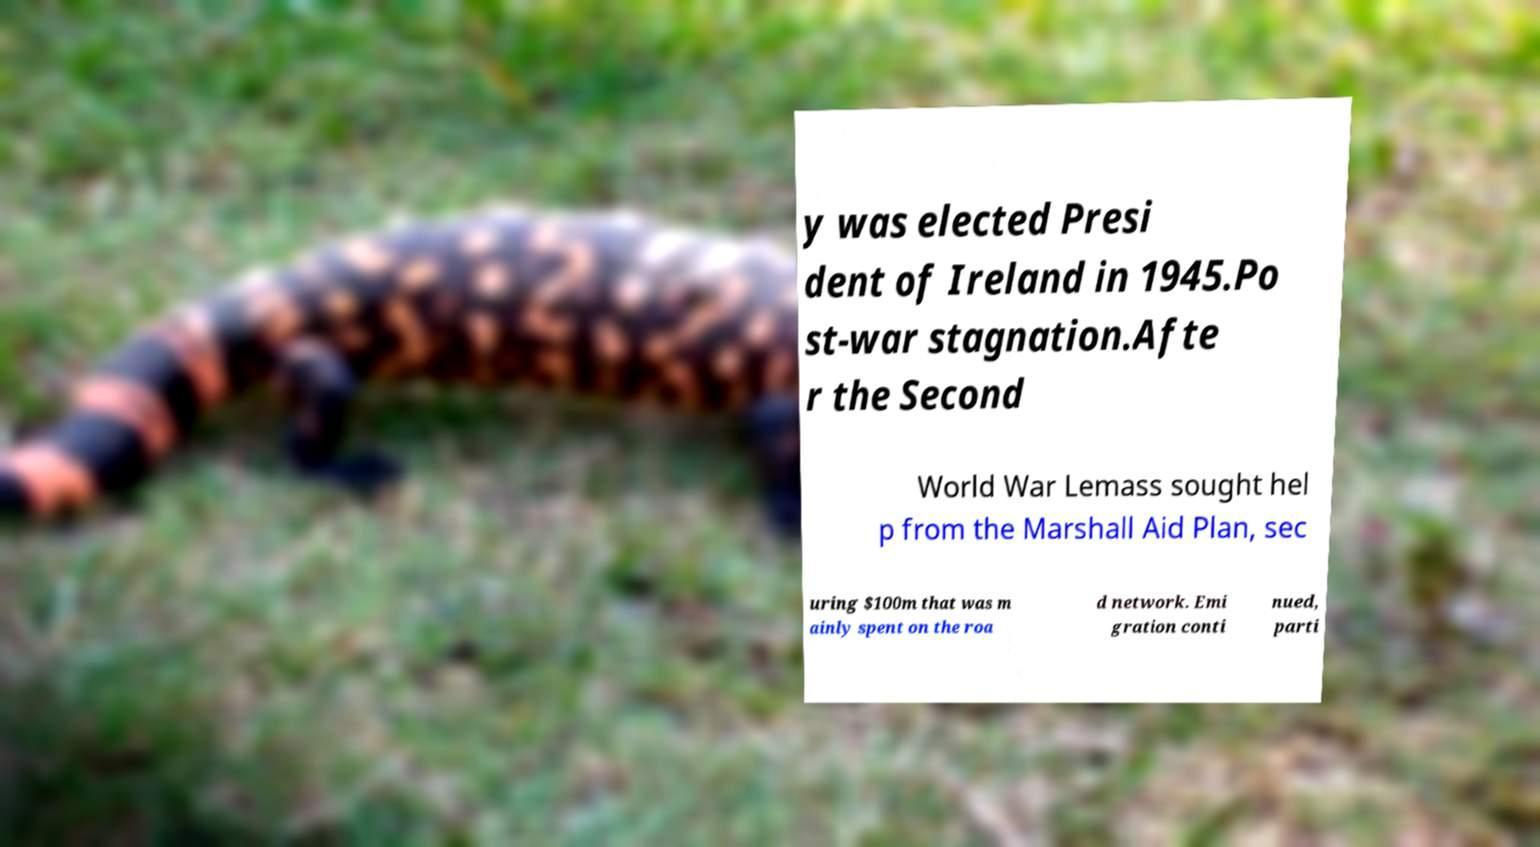I need the written content from this picture converted into text. Can you do that? y was elected Presi dent of Ireland in 1945.Po st-war stagnation.Afte r the Second World War Lemass sought hel p from the Marshall Aid Plan, sec uring $100m that was m ainly spent on the roa d network. Emi gration conti nued, parti 